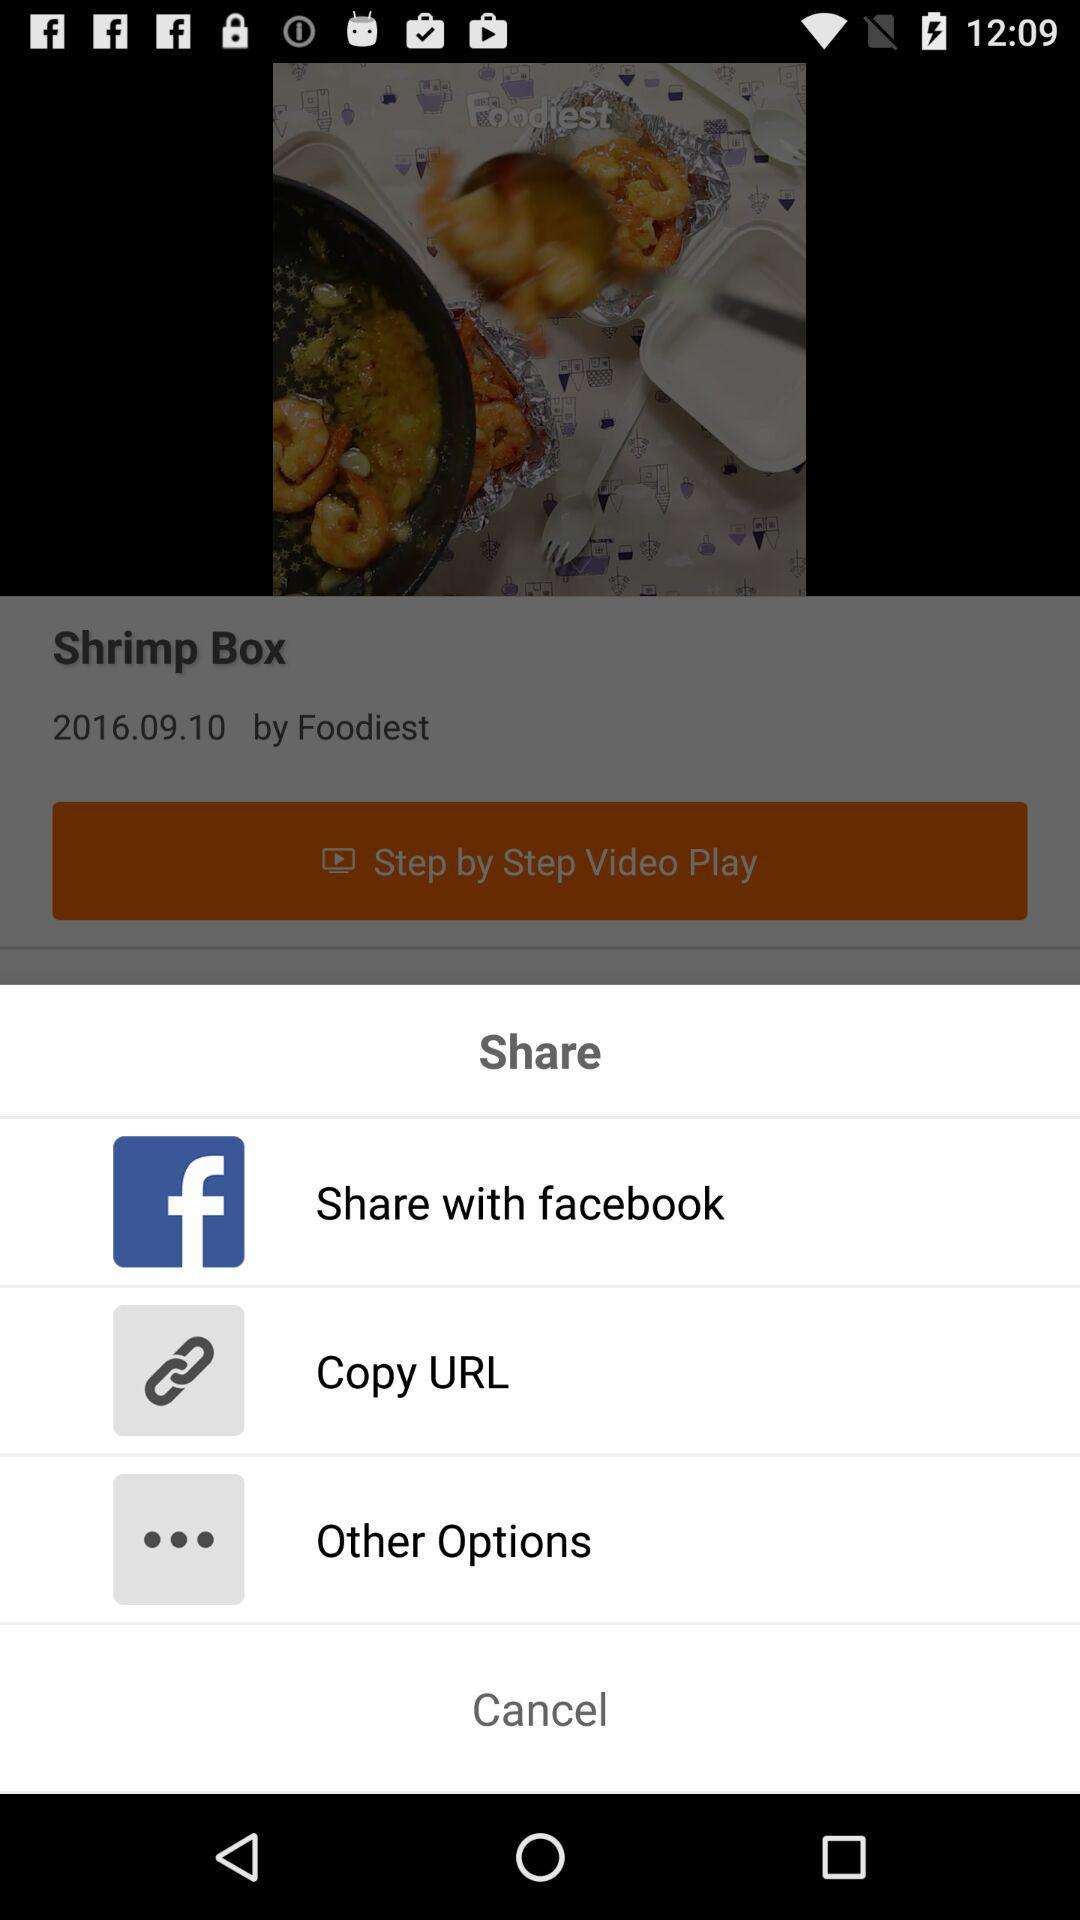What applications can be used to share? The application that can be used to share is "facebook". 